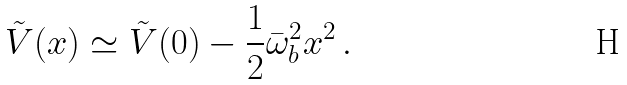Convert formula to latex. <formula><loc_0><loc_0><loc_500><loc_500>\tilde { V } ( x ) \simeq \tilde { V } ( 0 ) - \frac { 1 } { 2 } \bar { \omega } _ { b } ^ { 2 } x ^ { 2 } \, .</formula> 